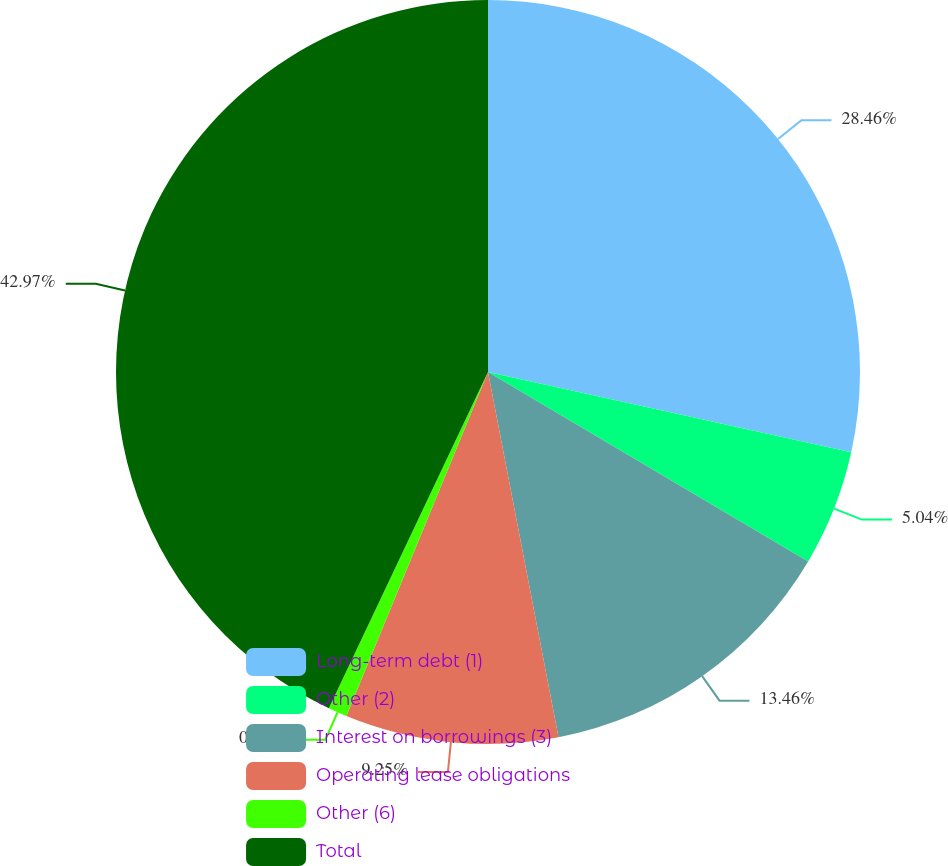Convert chart to OTSL. <chart><loc_0><loc_0><loc_500><loc_500><pie_chart><fcel>Long-term debt (1)<fcel>Other (2)<fcel>Interest on borrowings (3)<fcel>Operating lease obligations<fcel>Other (6)<fcel>Total<nl><fcel>28.46%<fcel>5.04%<fcel>13.46%<fcel>9.25%<fcel>0.82%<fcel>42.96%<nl></chart> 